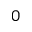Convert formula to latex. <formula><loc_0><loc_0><loc_500><loc_500>0</formula> 